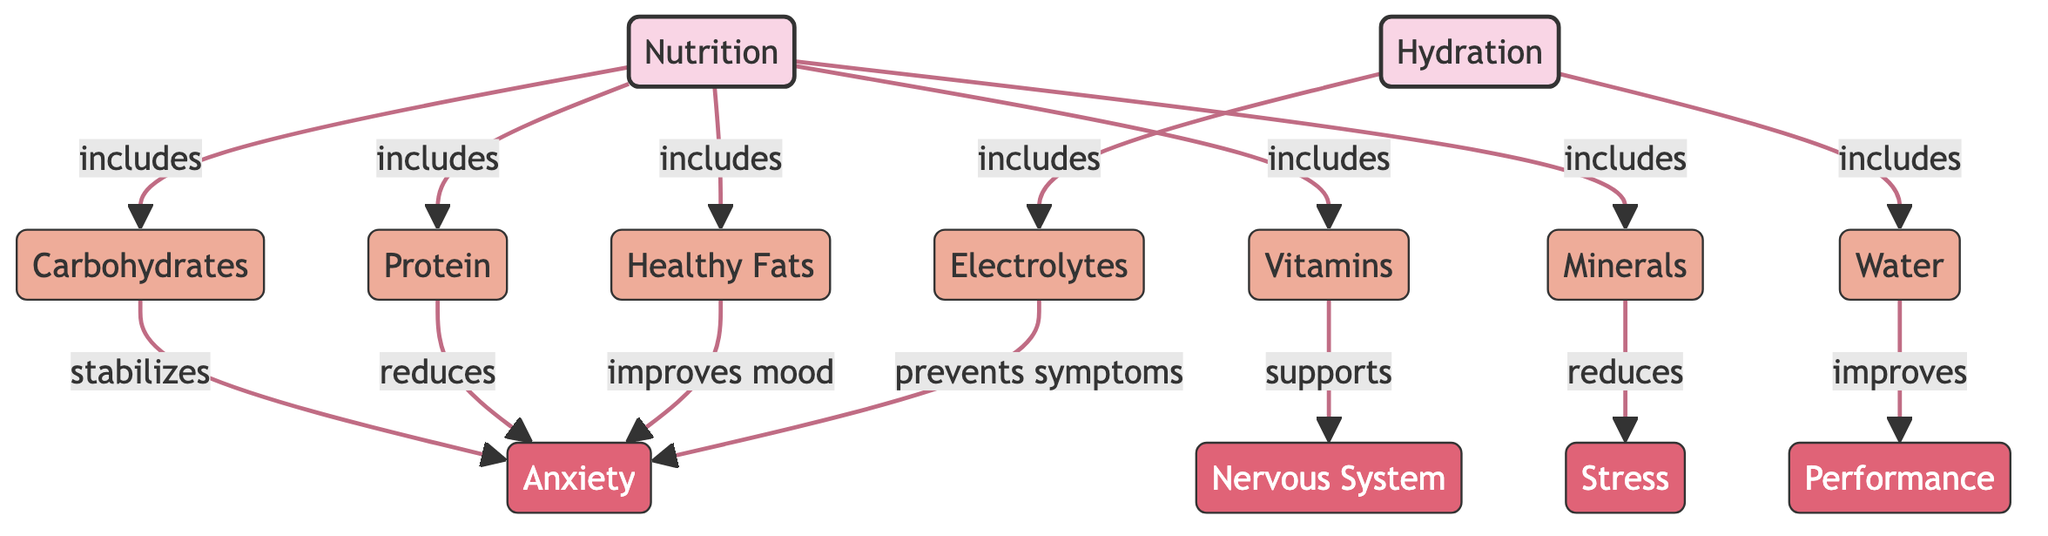What are the components of nutrition listed in the diagram? The components of nutrition shown in the diagram include carbohydrates, protein, healthy fats, vitamins, and minerals. These are explicitly connected to the main node for nutrition, indicating that they comprise it.
Answer: carbohydrates, protein, healthy fats, vitamins, minerals How many main nodes are present in the diagram? The diagram features two main nodes labeled "Nutrition" and "Hydration." Counting these nodes provides the answer.
Answer: 2 What effect does water have according to the diagram? The diagram indicates that water improves performance. This relationship is directly connected to the hydration node, leading to the effect node for performance.
Answer: improves performance Which nutrition component reduces anxiety? The diagram specifies that protein reduces anxiety. This relationship is shown where protein is directly connected to the effect node for anxiety.
Answer: protein How do electrolytes support anxiety management? According to the diagram, electrolytes prevent symptoms of anxiety. This indicates a protective function against anxiety-related outcomes.
Answer: prevents symptoms What is the relationship between minerals and stress? The diagram indicates that minerals reduce stress. This shows a direct link between the component of nutrition (minerals) and the effect node (stress), showing a negative correlation in the context of anxiety management.
Answer: reduces stress Which component is related to improving mood? The diagram states that healthy fats improve mood with a direct connection to the anxiety effect node. This suggests a positive relationship between healthy fats and mood regulation.
Answer: improves mood What role do vitamins play in relation to the nervous system? The diagram specifies that vitamins support the nervous system. This shows that vitamins are integral to maintaining nervous system function, likely contributing to better anxiety management.
Answer: supports nervous system 